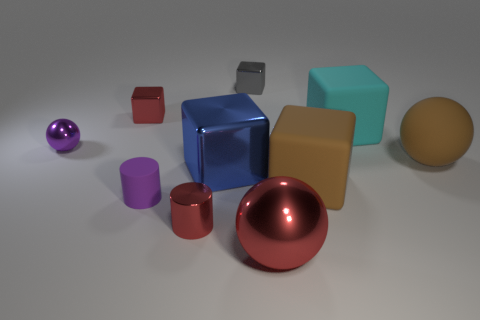Are any matte spheres visible?
Your answer should be compact. Yes. Do the cyan object and the shiny object that is to the right of the gray shiny cube have the same shape?
Give a very brief answer. No. What is the material of the tiny red object that is to the right of the tiny red object that is behind the tiny purple rubber cylinder?
Keep it short and to the point. Metal. The small rubber cylinder is what color?
Your answer should be very brief. Purple. There is a matte cube right of the brown rubber block; is its color the same as the small object to the right of the blue object?
Make the answer very short. No. What size is the gray thing that is the same shape as the blue thing?
Provide a short and direct response. Small. Are there any small metallic cylinders of the same color as the big rubber ball?
Keep it short and to the point. No. There is a big thing that is the same color as the big matte sphere; what material is it?
Your response must be concise. Rubber. How many big metal blocks are the same color as the tiny metal sphere?
Ensure brevity in your answer.  0. What number of objects are either small red metallic objects that are to the right of the small red metal cube or tiny gray metallic objects?
Make the answer very short. 2. 